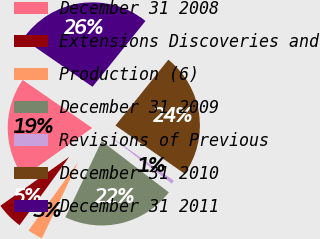Convert chart. <chart><loc_0><loc_0><loc_500><loc_500><pie_chart><fcel>December 31 2008<fcel>Extensions Discoveries and<fcel>Production (6)<fcel>December 31 2009<fcel>Revisions of Previous<fcel>December 31 2010<fcel>December 31 2011<nl><fcel>19.45%<fcel>5.17%<fcel>2.93%<fcel>21.69%<fcel>0.69%<fcel>23.92%<fcel>26.16%<nl></chart> 